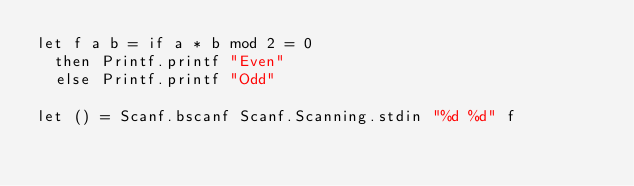<code> <loc_0><loc_0><loc_500><loc_500><_OCaml_>let f a b = if a * b mod 2 = 0
  then Printf.printf "Even"
  else Printf.printf "Odd"

let () = Scanf.bscanf Scanf.Scanning.stdin "%d %d" f
</code> 